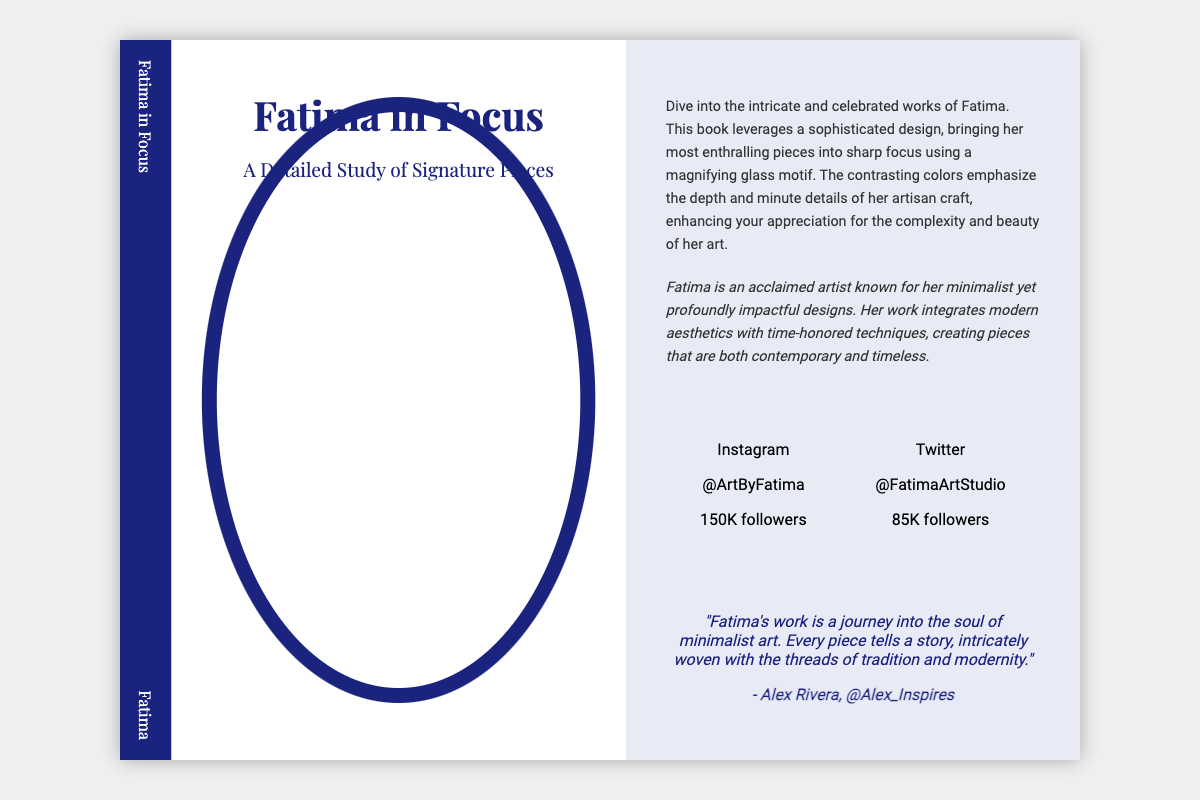what is the title of the book? The title of the book is prominently displayed in the front cover section of the document.
Answer: Fatima in Focus who is the author of the book? The author's name is mentioned on both the spine and the back cover of the book.
Answer: Fatima how many followers does Fatima have on Instagram? The number of Instagram followers is provided in the social media section of the document.
Answer: 150K followers what motif is used in the book design? The specific motif is described in the back cover's description of the book, emphasizing its design elements.
Answer: magnifying glass what colors are used in the book design? The colors are indicated in the description and by their use in the book's aesthetic, reflecting the overall theme.
Answer: contrasting colors what type of art does Fatima create? The author's bio provides insight into the style of art Fatima is known for creating.
Answer: minimalist who provided a quote about Fatima's work? The document includes a quote about Fatima's work attributed to a specific individual.
Answer: Alex Rivera what is the social media handle for Twitter? The document specifically states the Twitter handle in the social media section.
Answer: @FatimaArtStudio 